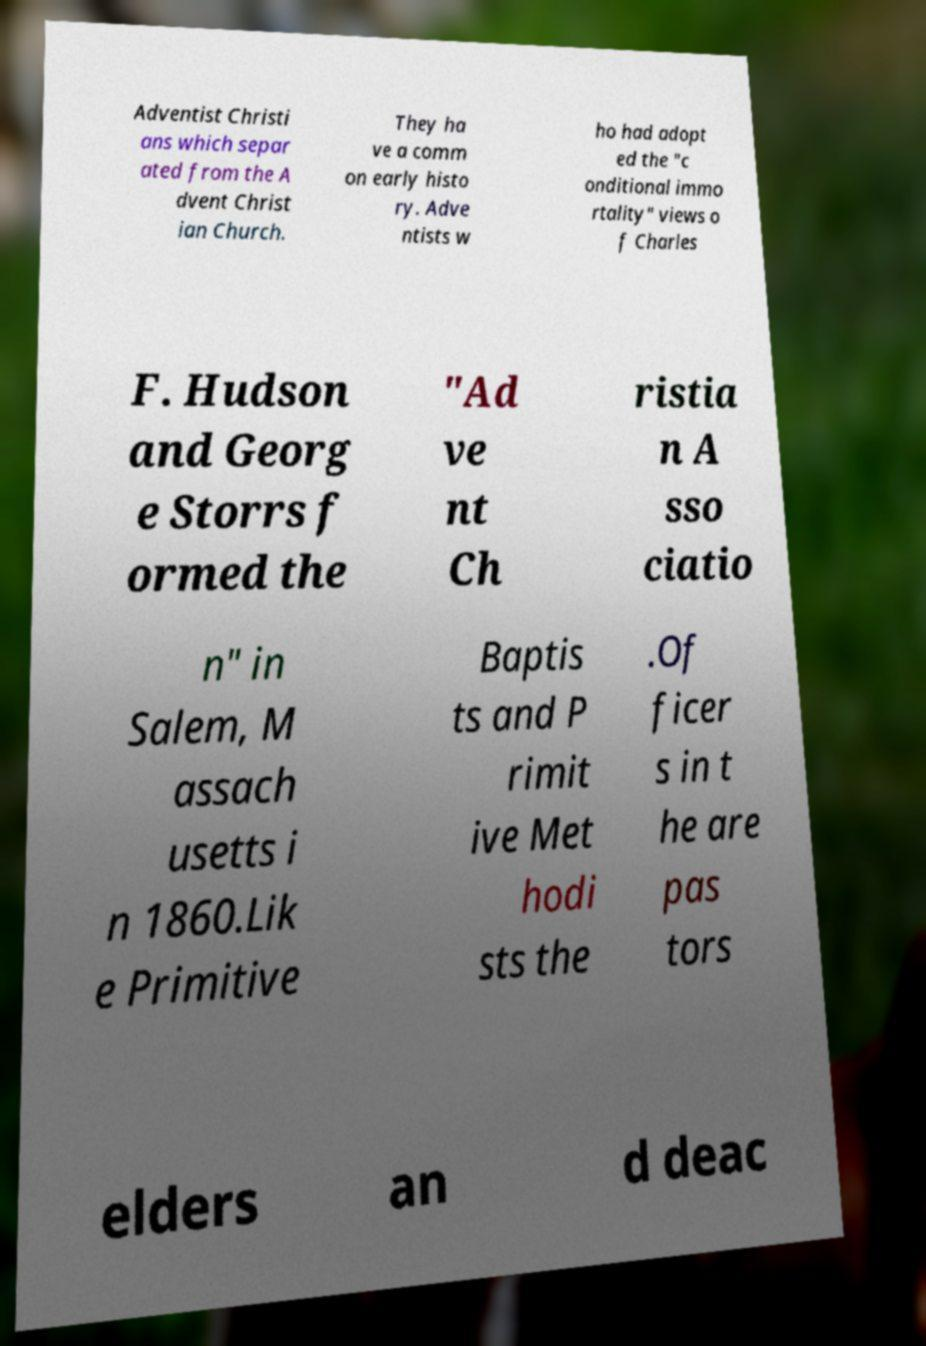Can you read and provide the text displayed in the image?This photo seems to have some interesting text. Can you extract and type it out for me? Adventist Christi ans which separ ated from the A dvent Christ ian Church. They ha ve a comm on early histo ry. Adve ntists w ho had adopt ed the "c onditional immo rtality" views o f Charles F. Hudson and Georg e Storrs f ormed the "Ad ve nt Ch ristia n A sso ciatio n" in Salem, M assach usetts i n 1860.Lik e Primitive Baptis ts and P rimit ive Met hodi sts the .Of ficer s in t he are pas tors elders an d deac 